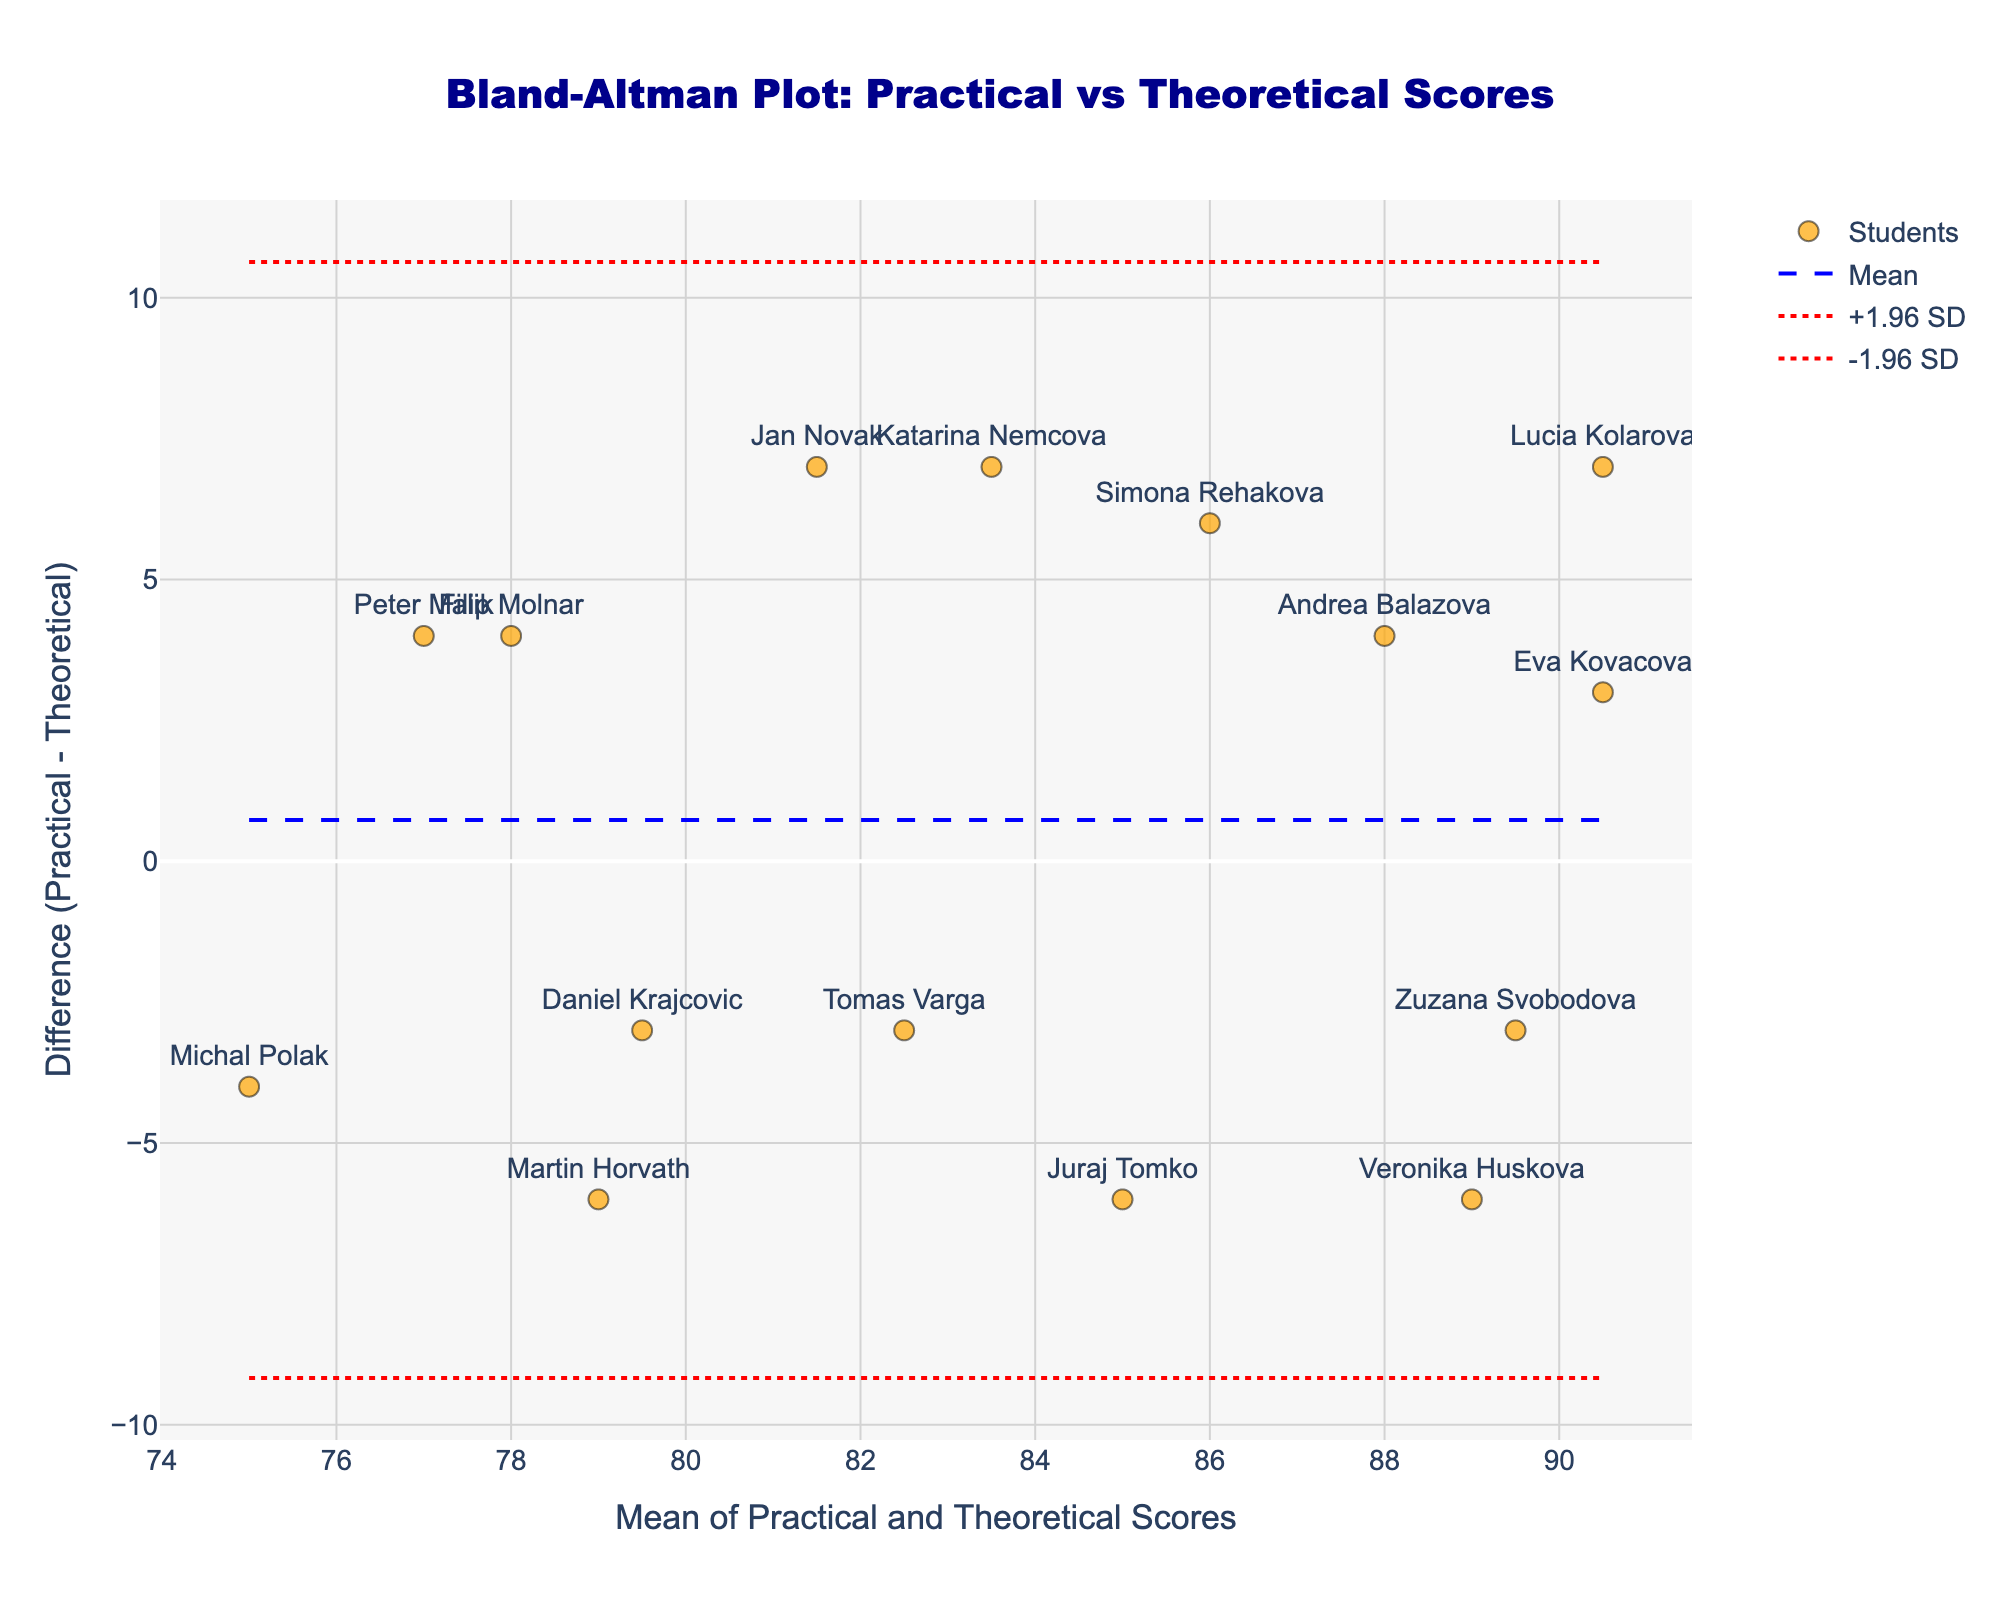What's the title of the plot? The title of the plot is always located at the top center of the figure. It provides an overview of what the plot represents. Here, the title is clearly written at the top.
Answer: Bland-Altman Plot: Practical vs Theoretical Scores What is the x-axis title? The x-axis title is printed below the x-axis and indicates what the horizontal axis represents. In this plot, you can see the title is directly below the axis.
Answer: Mean of Practical and Theoretical Scores What is the y-axis title? The y-axis title is printed next to the y-axis and indicates what the vertical axis represents. This is found along the edge of the y-axis.
Answer: Difference (Practical - Theoretical) How many students' performances are plotted? Each student's performance is represented as a point on the plot. By counting the individual points, we can determine the number of students.
Answer: 15 Which student has the highest mean score? The mean score of each student is calculated and plotted along the x-axis. The student with the highest mean score will be the rightmost point.
Answer: Lucia Kolarova What is the mean difference between practical and theoretical scores? The mean difference is represented by a horizontal dashed blue line in the plot. The y-value of this line indicates the mean difference.
Answer: 0.8 Do any students have a difference outside the ±1.96 SD limits? The ±1.96 SD limits are represented by the dotted red lines. Any point that falls outside these lines indicates a student with a difference beyond these limits.
Answer: No Which student has the largest negative difference between practical and theoretical scores? The vertical position of each point on the plot (y-axis) indicates the difference between practical and theoretical scores. The lowest point indicates the largest negative difference.
Answer: Katarina Nemcova What is the difference in practical and theoretical scores for Peter Malik? Need to locate Peter Malik's point labeled on the plot and check its y-value to determine the difference.
Answer: 4 